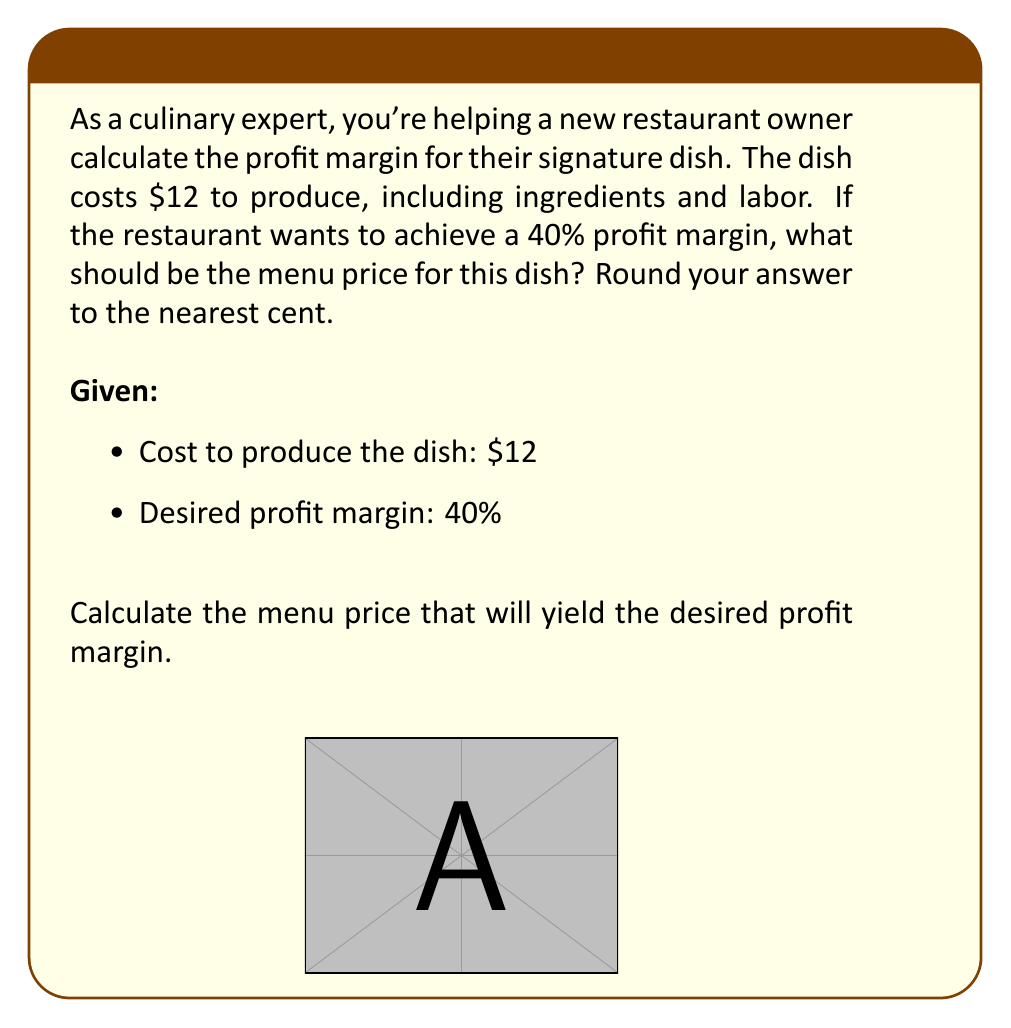What is the answer to this math problem? Let's break this down step-by-step:

1) First, we need to understand what profit margin means. Profit margin is the percentage of the selling price that is profit.

2) Let's define our variables:
   $x$ = selling price (menu price)
   $c$ = cost to produce the dish ($12)
   $m$ = desired profit margin (40% or 0.40)

3) The profit margin formula is:
   $m = \frac{\text{profit}}{\text{selling price}} = \frac{x - c}{x}$

4) We can set up our equation:
   $0.40 = \frac{x - 12}{x}$

5) Now, let's solve for $x$:
   $0.40x = x - 12$
   $0.40x - x = -12$
   $-0.60x = -12$

6) Divide both sides by -0.60:
   $x = \frac{-12}{-0.60} = 20$

7) Therefore, the menu price should be $20.

8) Let's verify:
   Profit = $20 - $12 = $8
   Profit margin = $\frac{8}{20} = 0.40$ or 40%

This confirms our calculation is correct.
Answer: $20 